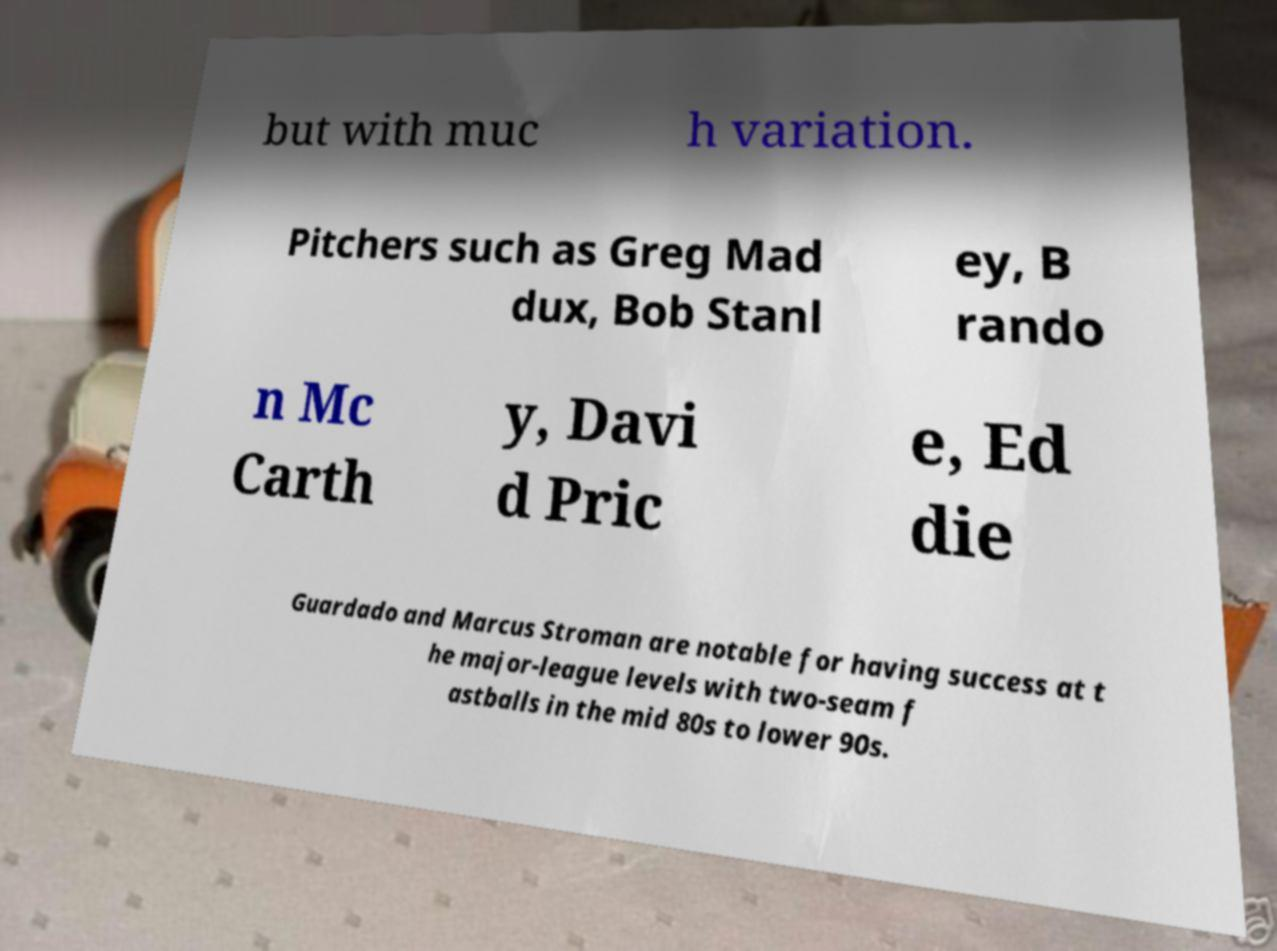Could you assist in decoding the text presented in this image and type it out clearly? but with muc h variation. Pitchers such as Greg Mad dux, Bob Stanl ey, B rando n Mc Carth y, Davi d Pric e, Ed die Guardado and Marcus Stroman are notable for having success at t he major-league levels with two-seam f astballs in the mid 80s to lower 90s. 